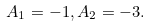Convert formula to latex. <formula><loc_0><loc_0><loc_500><loc_500>A _ { 1 } = - 1 , A _ { 2 } = - 3 .</formula> 